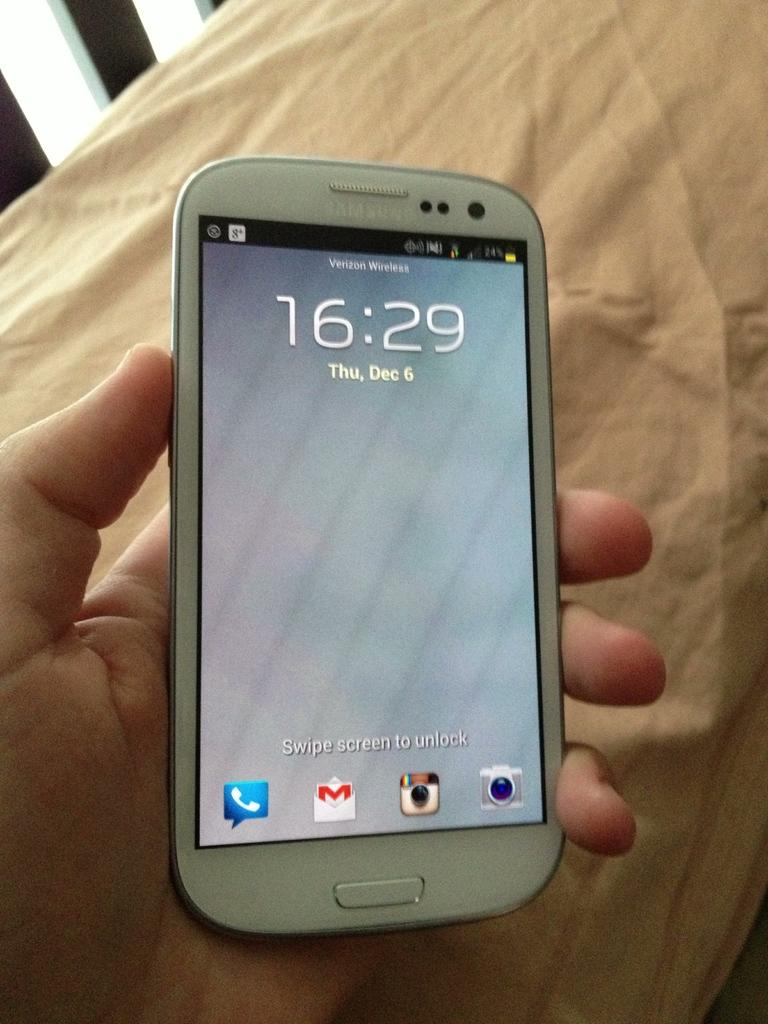<image>
Share a concise interpretation of the image provided. A lock screen displaying a time of 16:29 